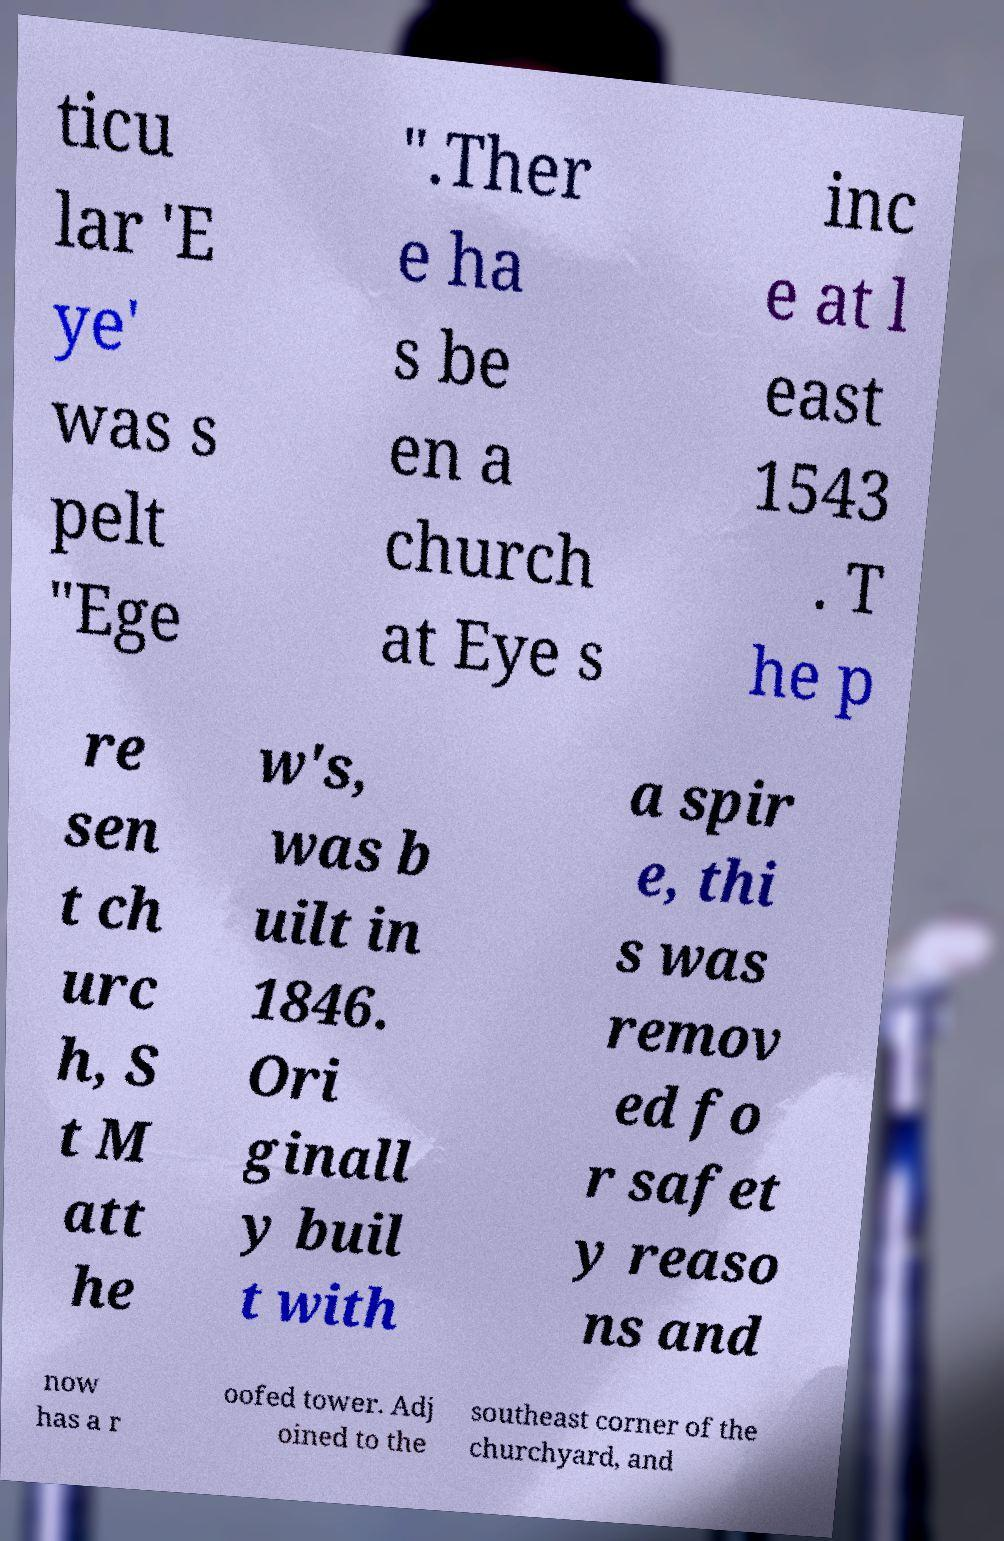I need the written content from this picture converted into text. Can you do that? ticu lar 'E ye' was s pelt "Ege ".Ther e ha s be en a church at Eye s inc e at l east 1543 . T he p re sen t ch urc h, S t M att he w's, was b uilt in 1846. Ori ginall y buil t with a spir e, thi s was remov ed fo r safet y reaso ns and now has a r oofed tower. Adj oined to the southeast corner of the churchyard, and 